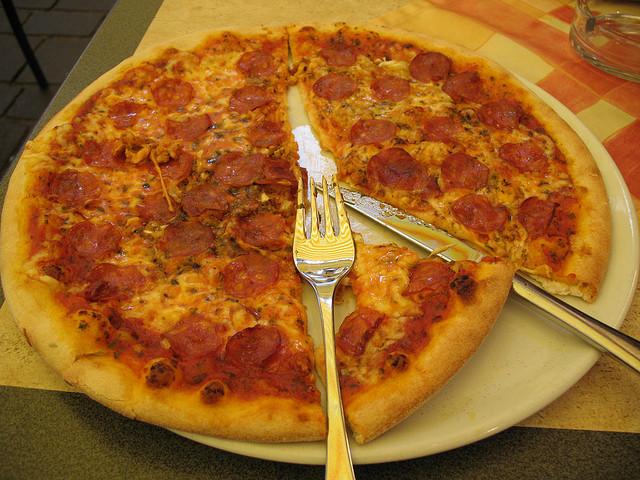Is the fork touching the knife?
Answer briefly. Yes. Is the entire pizza cut into slices?
Answer briefly. No. What is the snack is on the table?
Give a very brief answer. Pizza. 